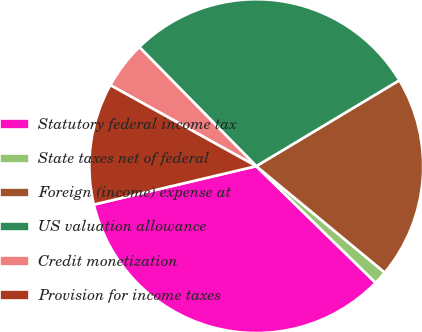<chart> <loc_0><loc_0><loc_500><loc_500><pie_chart><fcel>Statutory federal income tax<fcel>State taxes net of federal<fcel>Foreign (income) expense at<fcel>US valuation allowance<fcel>Credit monetization<fcel>Provision for income taxes<nl><fcel>33.99%<fcel>1.31%<fcel>19.61%<fcel>28.76%<fcel>4.58%<fcel>11.76%<nl></chart> 